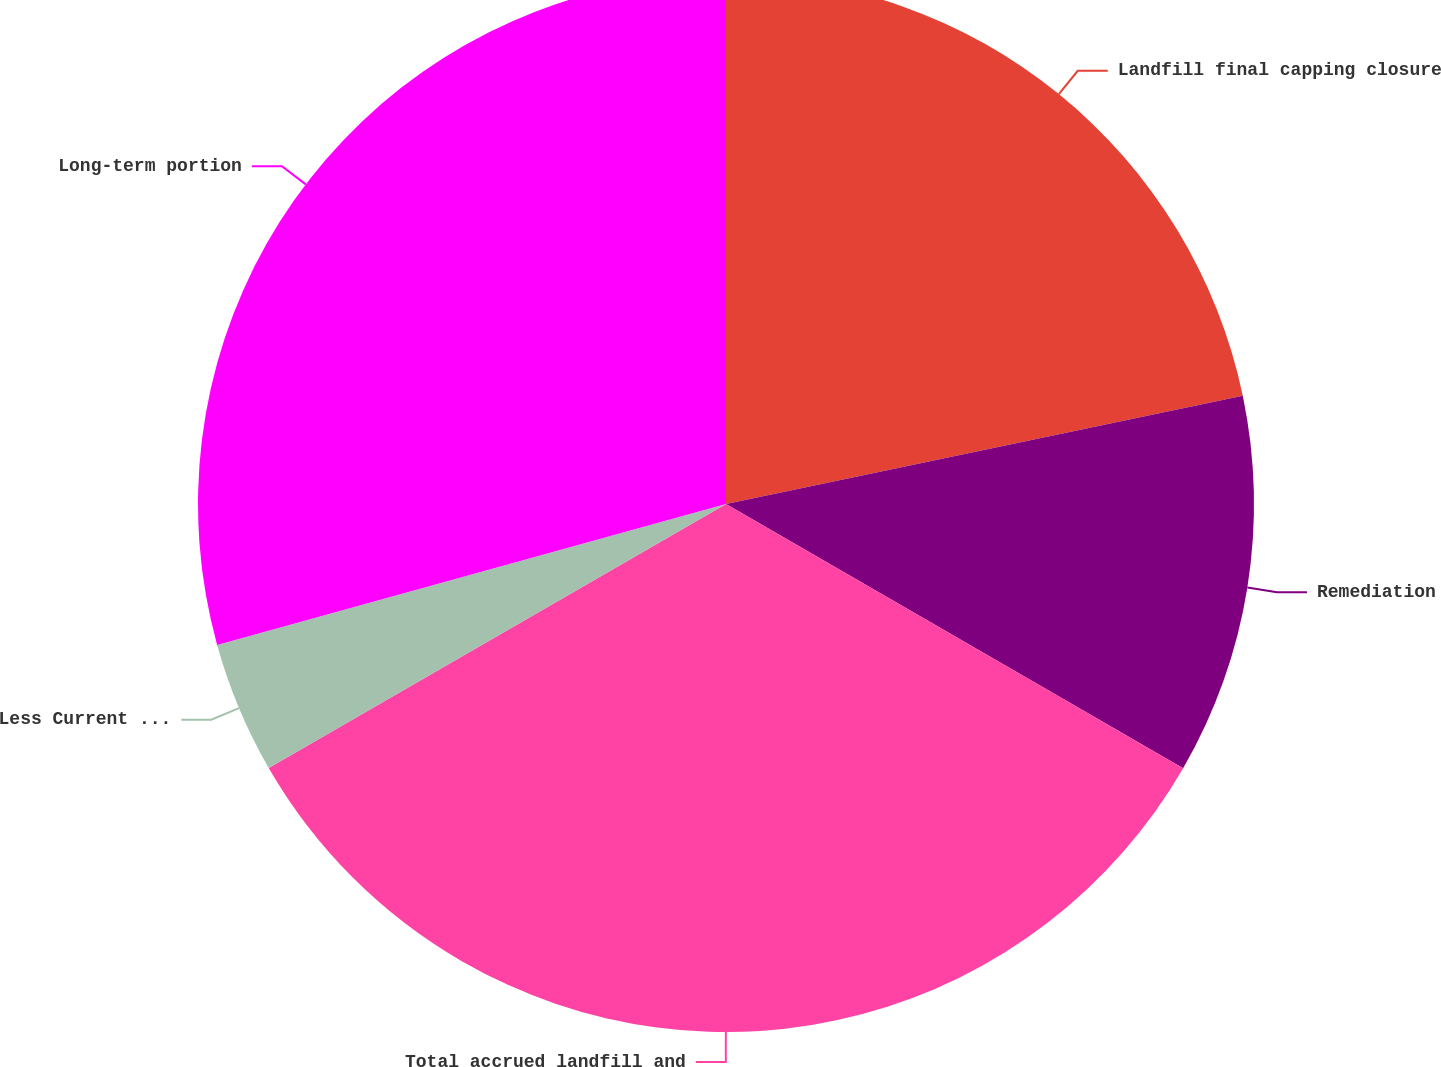<chart> <loc_0><loc_0><loc_500><loc_500><pie_chart><fcel>Landfill final capping closure<fcel>Remediation<fcel>Total accrued landfill and<fcel>Less Current portion<fcel>Long-term portion<nl><fcel>21.71%<fcel>11.63%<fcel>33.33%<fcel>4.03%<fcel>29.3%<nl></chart> 